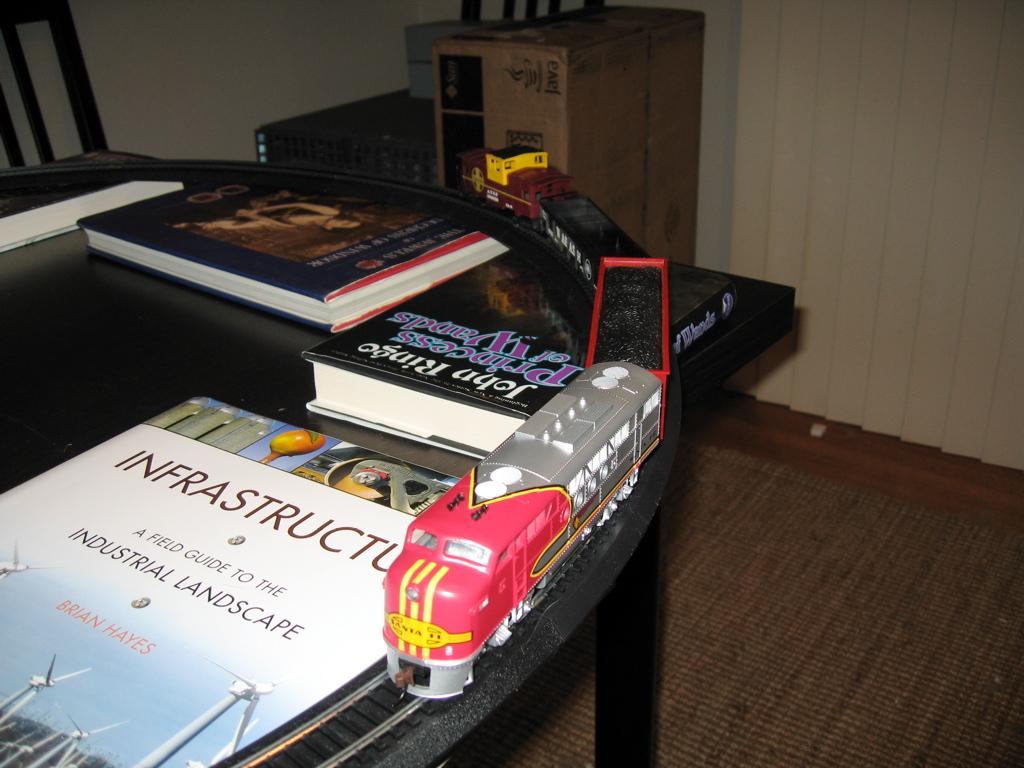What is this a guide to?
Provide a succinct answer. Industrial landscape. 